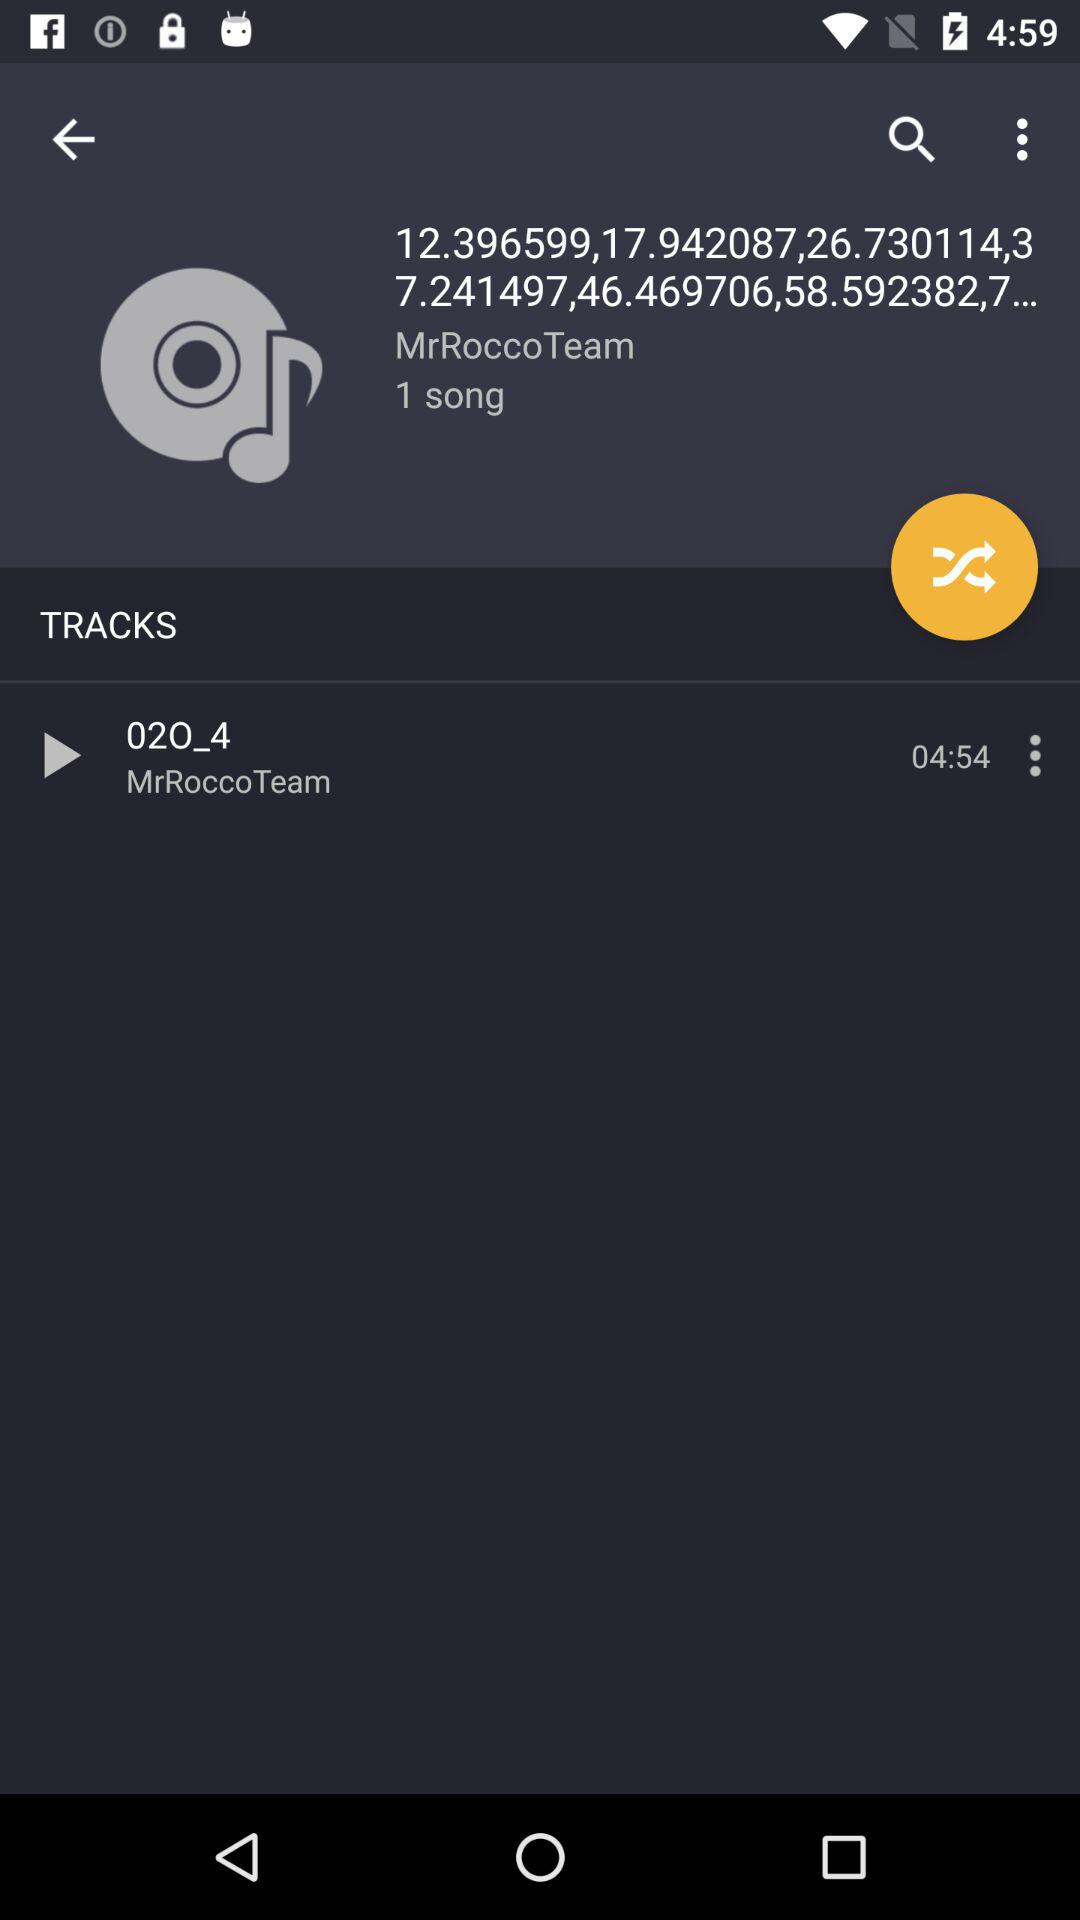What is the name of author?
When the provided information is insufficient, respond with <no answer>. <no answer> 